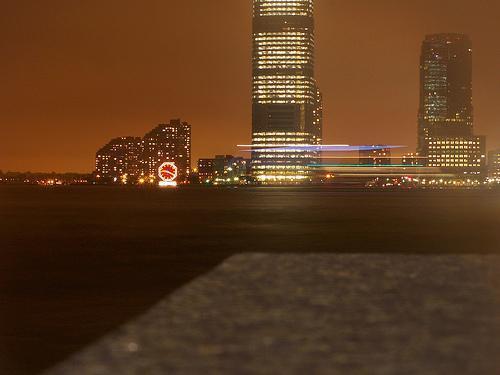How many skyscrapers are there?
Give a very brief answer. 2. 